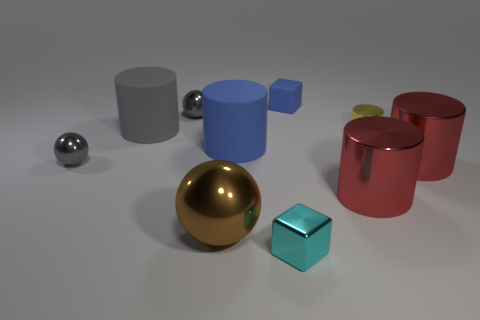Subtract all blue cylinders. How many cylinders are left? 4 Subtract 2 cylinders. How many cylinders are left? 3 Subtract all tiny shiny cylinders. How many cylinders are left? 4 Subtract all gray cylinders. Subtract all green blocks. How many cylinders are left? 4 Subtract all blocks. How many objects are left? 8 Subtract all large green cylinders. Subtract all cyan things. How many objects are left? 9 Add 4 large cylinders. How many large cylinders are left? 8 Add 2 tiny yellow things. How many tiny yellow things exist? 3 Subtract 1 yellow cylinders. How many objects are left? 9 